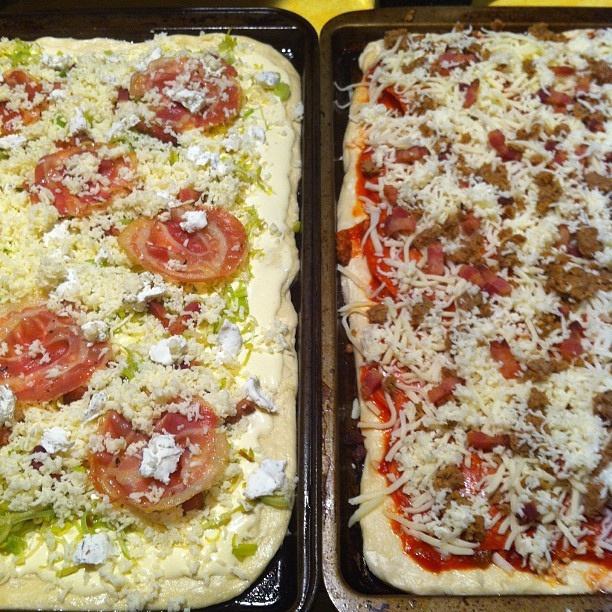Describe the objects in this image and their specific colors. I can see pizza in black, khaki, beige, tan, and brown tones and pizza in black, darkgray, and tan tones in this image. 